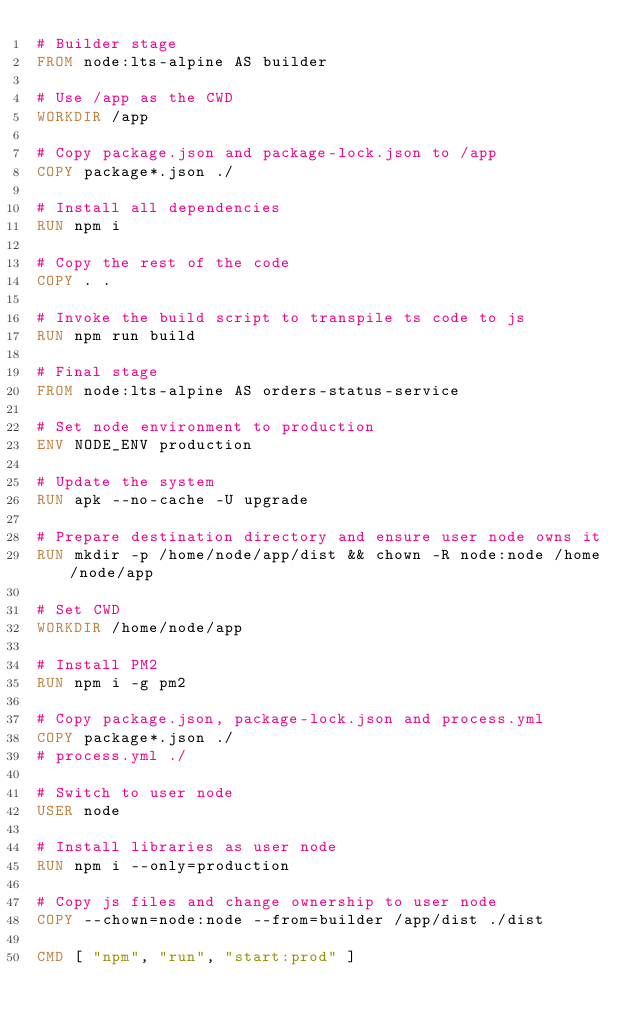<code> <loc_0><loc_0><loc_500><loc_500><_Dockerfile_># Builder stage
FROM node:lts-alpine AS builder

# Use /app as the CWD
WORKDIR /app            

# Copy package.json and package-lock.json to /app
COPY package*.json ./   

# Install all dependencies
RUN npm i 

# Copy the rest of the code
COPY . . 

# Invoke the build script to transpile ts code to js
RUN npm run build

# Final stage
FROM node:lts-alpine AS orders-status-service

# Set node environment to production
ENV NODE_ENV production

# Update the system
RUN apk --no-cache -U upgrade

# Prepare destination directory and ensure user node owns it
RUN mkdir -p /home/node/app/dist && chown -R node:node /home/node/app

# Set CWD
WORKDIR /home/node/app

# Install PM2
RUN npm i -g pm2

# Copy package.json, package-lock.json and process.yml
COPY package*.json ./
# process.yml ./

# Switch to user node
USER node

# Install libraries as user node
RUN npm i --only=production

# Copy js files and change ownership to user node
COPY --chown=node:node --from=builder /app/dist ./dist

CMD [ "npm", "run", "start:prod" ]</code> 